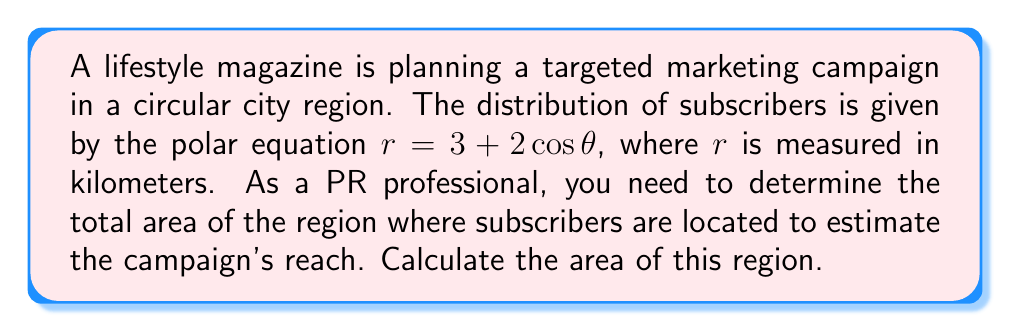Could you help me with this problem? To solve this problem, we need to follow these steps:

1) The area of a region in polar coordinates is given by the formula:

   $$ A = \frac{1}{2} \int_0^{2\pi} r^2 d\theta $$

2) We are given that $r = 3 + 2\cos\theta$. We need to square this:

   $$ r^2 = (3 + 2\cos\theta)^2 = 9 + 12\cos\theta + 4\cos^2\theta $$

3) Now we can set up our integral:

   $$ A = \frac{1}{2} \int_0^{2\pi} (9 + 12\cos\theta + 4\cos^2\theta) d\theta $$

4) Let's integrate each term separately:

   $\int_0^{2\pi} 9 d\theta = 9\theta |_0^{2\pi} = 18\pi$

   $\int_0^{2\pi} 12\cos\theta d\theta = 12\sin\theta |_0^{2\pi} = 0$

   $\int_0^{2\pi} 4\cos^2\theta d\theta = 4 \cdot \frac{1}{2} \cdot 2\pi = 4\pi$

5) Adding these results:

   $$ A = \frac{1}{2} (18\pi + 0 + 4\pi) = 11\pi $$

6) Therefore, the total area is $11\pi$ square kilometers.
Answer: $11\pi$ square kilometers 